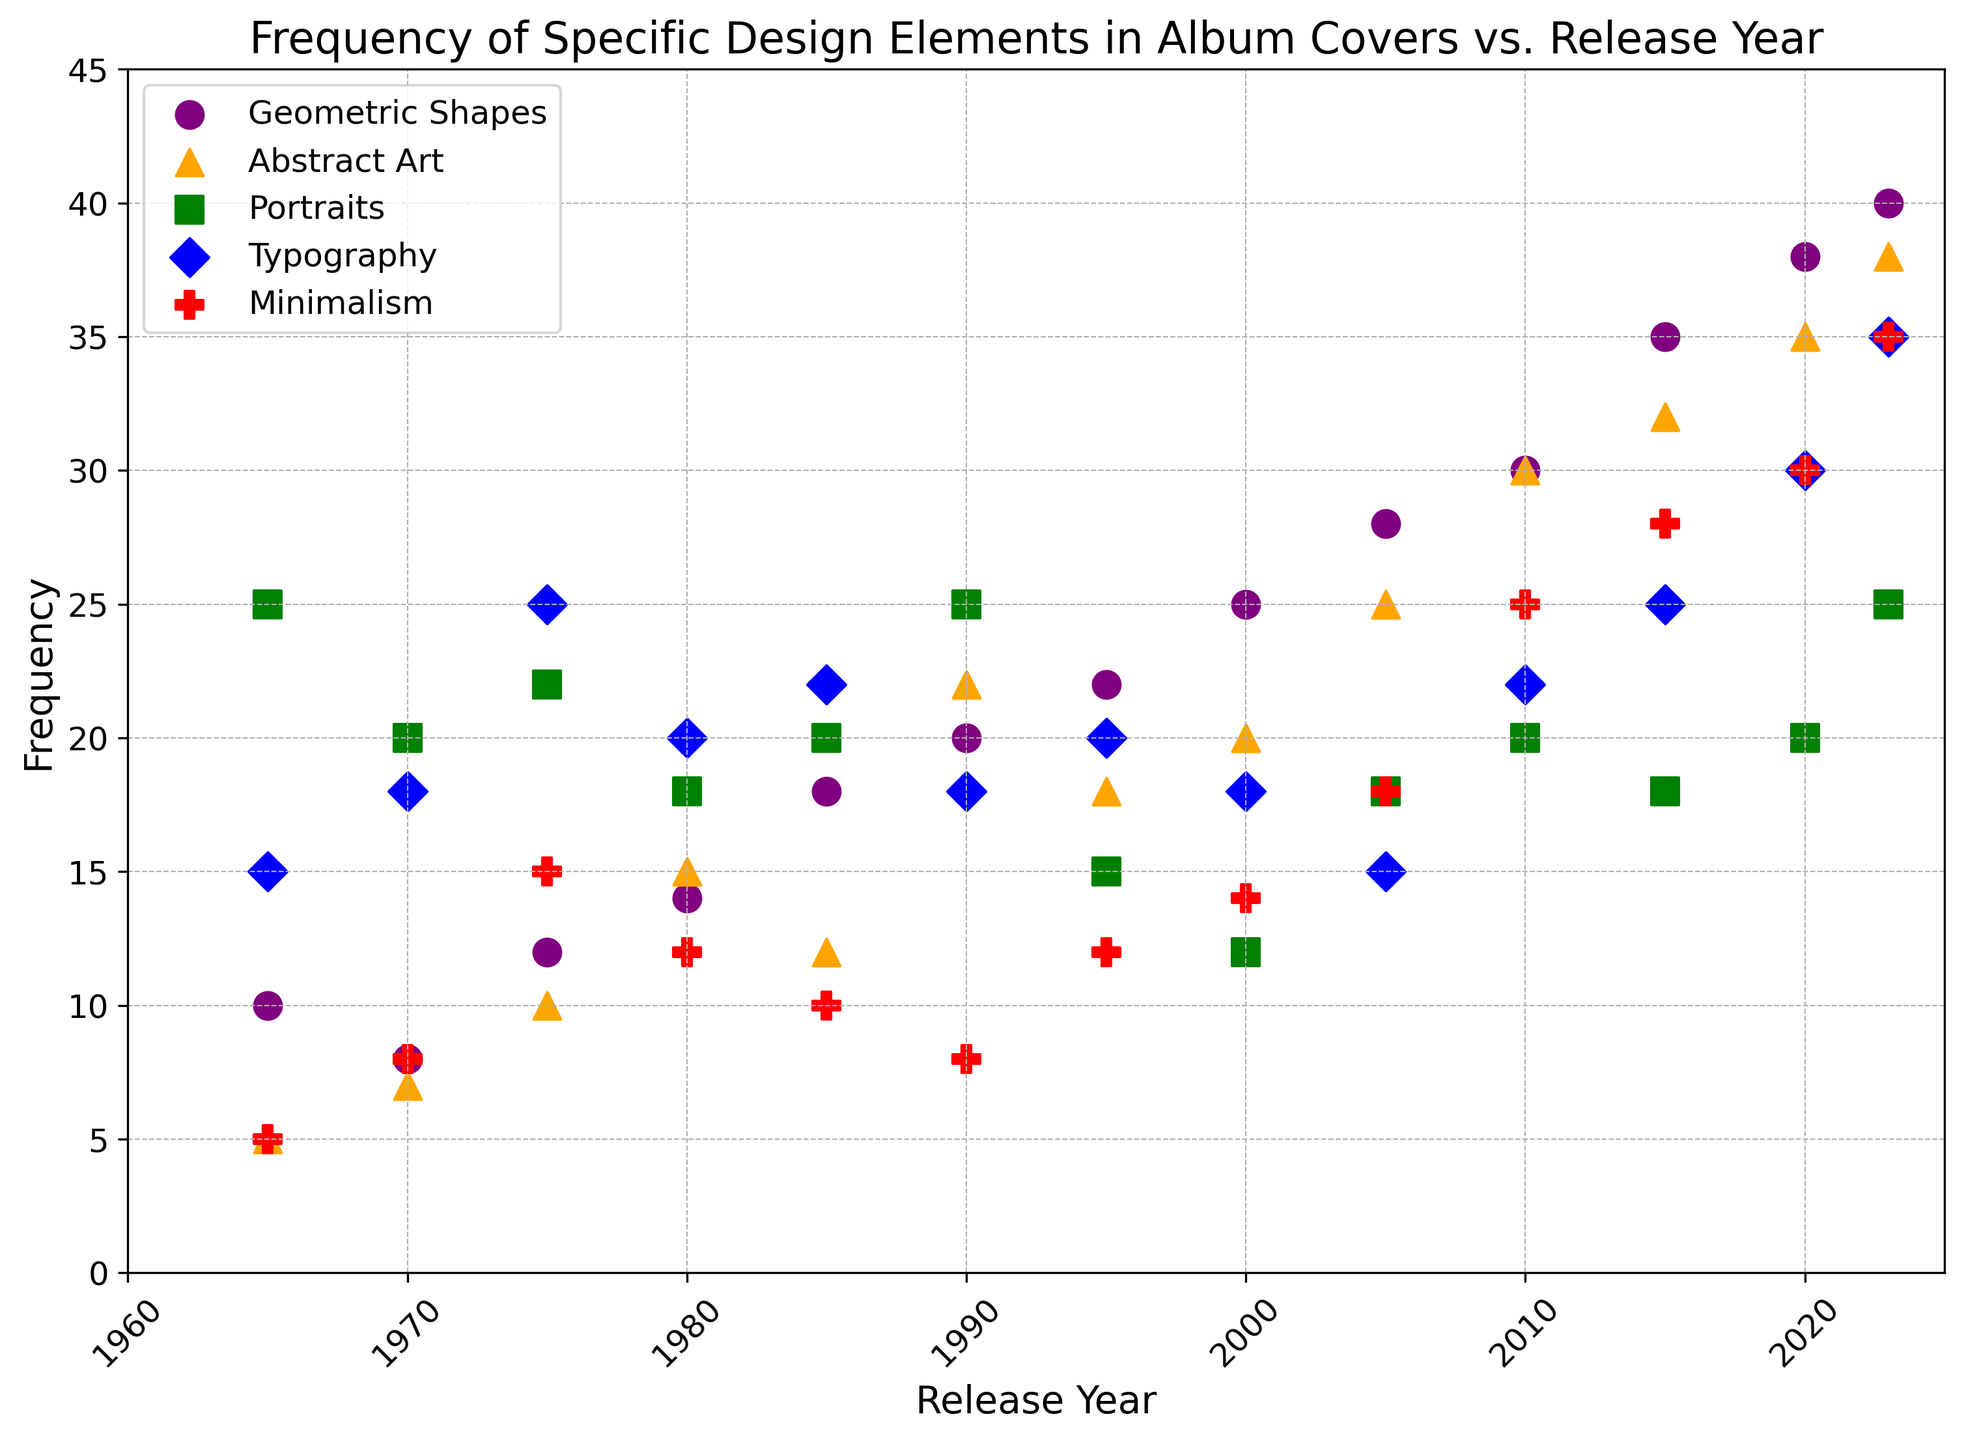What's the frequency of Abstract Art in 2015? To find this, look at the data point for Abstract Art in the year 2015 from the plot. The frequency is marked by the orange triangle at the vertical level of the y-axis. The data indicates the marker position at 32.
Answer: 32 Which design element has the highest frequency in 2023? Examine the data points for all design elements in the year 2023. The highest point on the y-axis corresponds to Geometric Shapes, represented as a purple circle at 40.
Answer: Geometric Shapes What is the difference in frequency of Typography between 1975 and 1990? Locate Typography values for 1975 and 1990 on the plot. The frequency in 1975 is marked by a blue diamond at 25, and in 1990, it is at 18. The difference is 25 - 18 = 7.
Answer: 7 How does the frequency of Minimalism in 2010 compare to that in 2023? Find the frequency of Minimalism for both years from the plot. In 2010, Minimalism is at 25 (red pentagon), and in 2023, it is at 35. Thus, 35 is greater than 25.
Answer: 35 > 25 What is the average frequency of Geometric Shapes over the years 1980, 1990, and 2000? For these years, the Geometric Shapes frequencies are 14 (1980), 20 (1990), and 25 (2000). Sum these values: 14 + 20 + 25 = 59, then divide by 3 to get the average: 59 / 3 ≈ 19.67.
Answer: 19.67 Between 1970 and 2005, in which year does Abstract Art have the lowest frequency? Check the Abstract Art frequencies for these years: 1970 (7), 1975 (10), 1980 (15), 1985 (12), 1990 (22), 1995 (18), 2000 (20), and 2005 (25). The lowest value is in 1970 with a frequency of 7.
Answer: 1970 What is the total frequency of Portraits across 1985, 1995, and 2010? Sum the frequencies for Portraits in these years from the plot: 1985 (20), 1995 (15), and 2010 (20). Sum is 20 + 15 + 20 = 55.
Answer: 55 How does the frequency of Minimalism change from 2005 to 2020? From the plot, find that Minimalism changes from 18 in 2005 to 30 in 2020. The frequency increases by 30 - 18 = 12.
Answer: Increased by 12 Which design element shows a steady increase over the years and reaches 38 by 2023? Check all design elements over time to identify a consistent increasing trend. Geometric Shapes show a steady rise, culminating in 38 by 2023.
Answer: Geometric Shapes What is the combined frequency of all design elements in the year 1980? Sum up all frequencies for 1980 from the plot: Geometric Shapes (14), Abstract Art (15), Portraits (18), Typography (20), and Minimalism (12): 14 + 15 + 18 + 20 + 12 = 79.
Answer: 79 